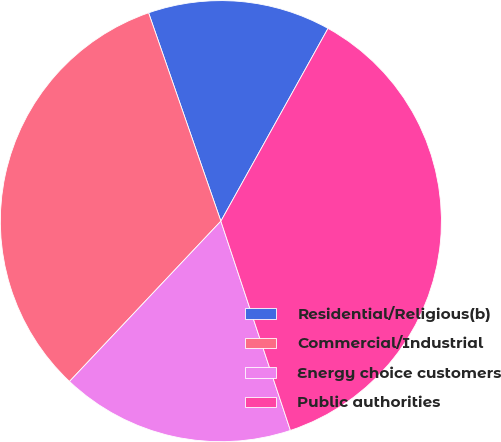<chart> <loc_0><loc_0><loc_500><loc_500><pie_chart><fcel>Residential/Religious(b)<fcel>Commercial/Industrial<fcel>Energy choice customers<fcel>Public authorities<nl><fcel>13.39%<fcel>32.64%<fcel>17.15%<fcel>36.82%<nl></chart> 